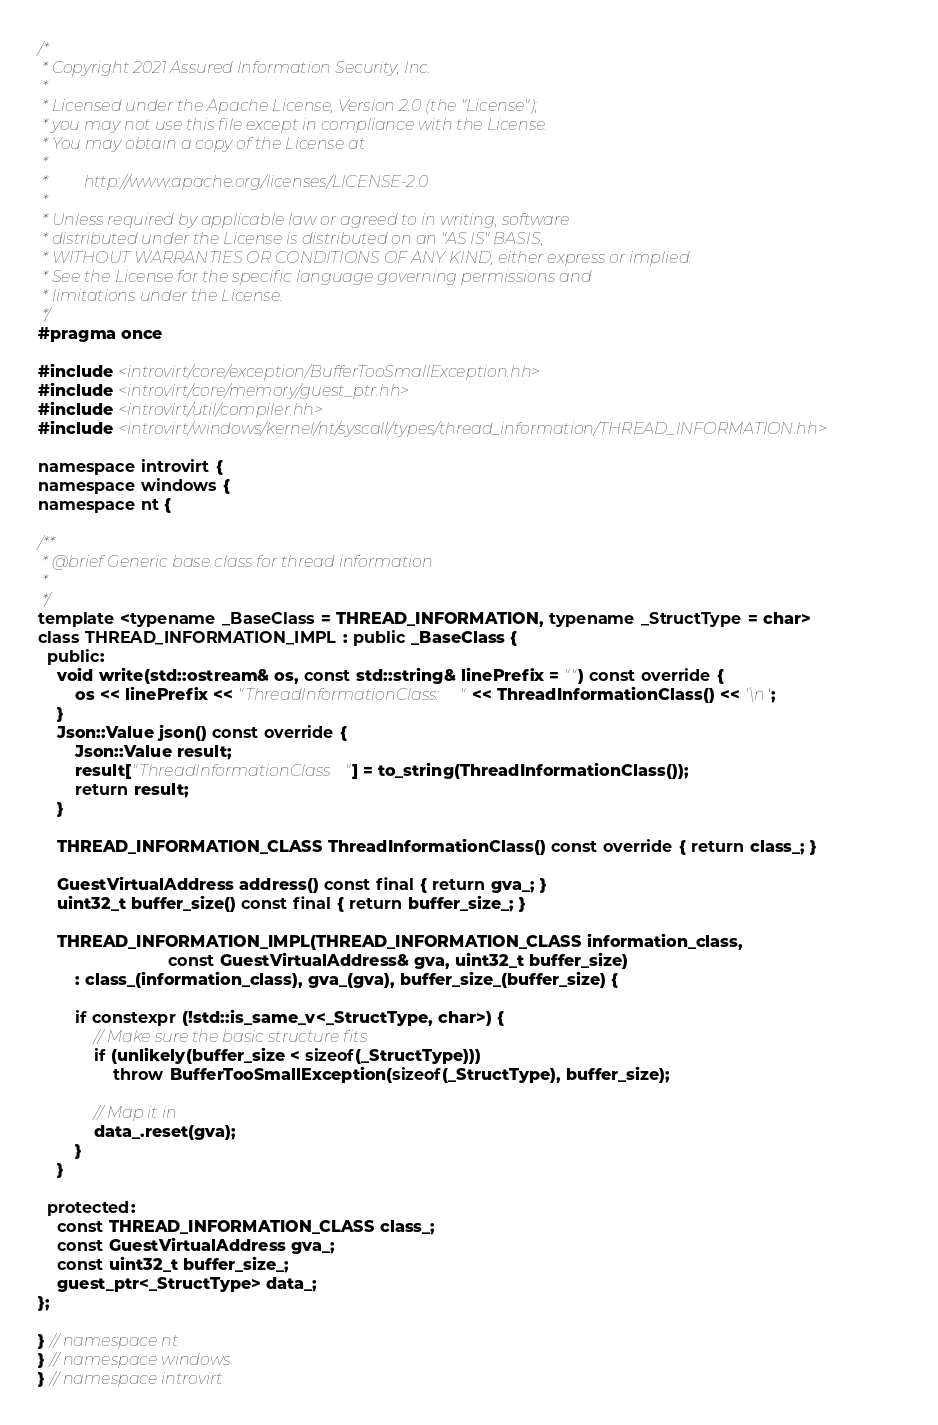Convert code to text. <code><loc_0><loc_0><loc_500><loc_500><_C++_>/*
 * Copyright 2021 Assured Information Security, Inc.
 *
 * Licensed under the Apache License, Version 2.0 (the "License");
 * you may not use this file except in compliance with the License.
 * You may obtain a copy of the License at
 *
 *         http://www.apache.org/licenses/LICENSE-2.0
 *
 * Unless required by applicable law or agreed to in writing, software
 * distributed under the License is distributed on an "AS IS" BASIS,
 * WITHOUT WARRANTIES OR CONDITIONS OF ANY KIND, either express or implied.
 * See the License for the specific language governing permissions and
 * limitations under the License.
 */
#pragma once

#include <introvirt/core/exception/BufferTooSmallException.hh>
#include <introvirt/core/memory/guest_ptr.hh>
#include <introvirt/util/compiler.hh>
#include <introvirt/windows/kernel/nt/syscall/types/thread_information/THREAD_INFORMATION.hh>

namespace introvirt {
namespace windows {
namespace nt {

/**
 * @brief Generic base class for thread information
 *
 */
template <typename _BaseClass = THREAD_INFORMATION, typename _StructType = char>
class THREAD_INFORMATION_IMPL : public _BaseClass {
  public:
    void write(std::ostream& os, const std::string& linePrefix = "") const override {
        os << linePrefix << "ThreadInformationClass: " << ThreadInformationClass() << '\n';
    }
    Json::Value json() const override {
        Json::Value result;
        result["ThreadInformationClass"] = to_string(ThreadInformationClass());
        return result;
    }

    THREAD_INFORMATION_CLASS ThreadInformationClass() const override { return class_; }

    GuestVirtualAddress address() const final { return gva_; }
    uint32_t buffer_size() const final { return buffer_size_; }

    THREAD_INFORMATION_IMPL(THREAD_INFORMATION_CLASS information_class,
                            const GuestVirtualAddress& gva, uint32_t buffer_size)
        : class_(information_class), gva_(gva), buffer_size_(buffer_size) {

        if constexpr (!std::is_same_v<_StructType, char>) {
            // Make sure the basic structure fits
            if (unlikely(buffer_size < sizeof(_StructType)))
                throw BufferTooSmallException(sizeof(_StructType), buffer_size);

            // Map it in
            data_.reset(gva);
        }
    }

  protected:
    const THREAD_INFORMATION_CLASS class_;
    const GuestVirtualAddress gva_;
    const uint32_t buffer_size_;
    guest_ptr<_StructType> data_;
};

} // namespace nt
} // namespace windows
} // namespace introvirt</code> 